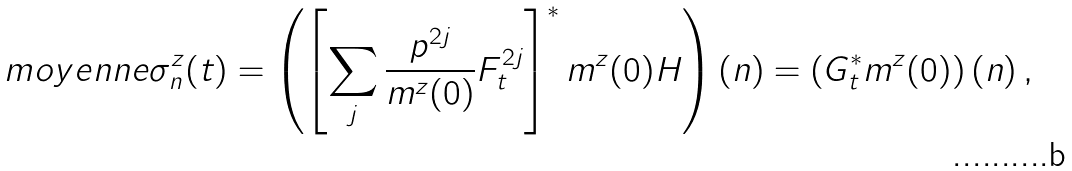Convert formula to latex. <formula><loc_0><loc_0><loc_500><loc_500>\ m o y e n n e { \sigma _ { n } ^ { z } } ( t ) = \left ( \left [ \sum _ { j } \frac { p ^ { 2 j } } { m ^ { z } ( 0 ) } F _ { t } ^ { 2 j } \right ] ^ { * } m ^ { z } ( 0 ) H \right ) ( n ) = \left ( G _ { t } ^ { * } m ^ { z } ( 0 ) \right ) ( n ) \, ,</formula> 